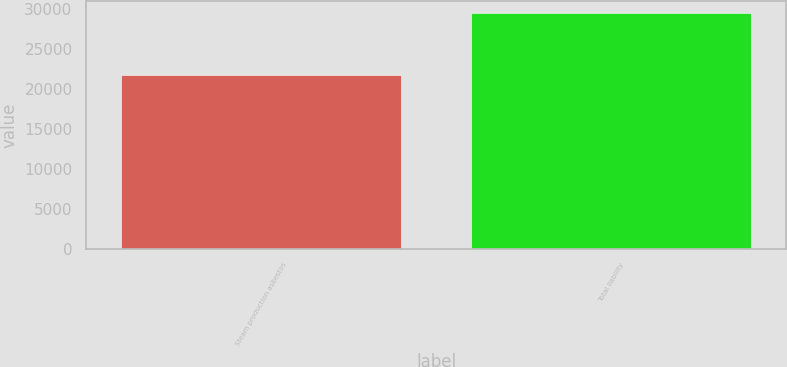Convert chart. <chart><loc_0><loc_0><loc_500><loc_500><bar_chart><fcel>Steam production asbestos<fcel>Total liability<nl><fcel>21721<fcel>29464<nl></chart> 